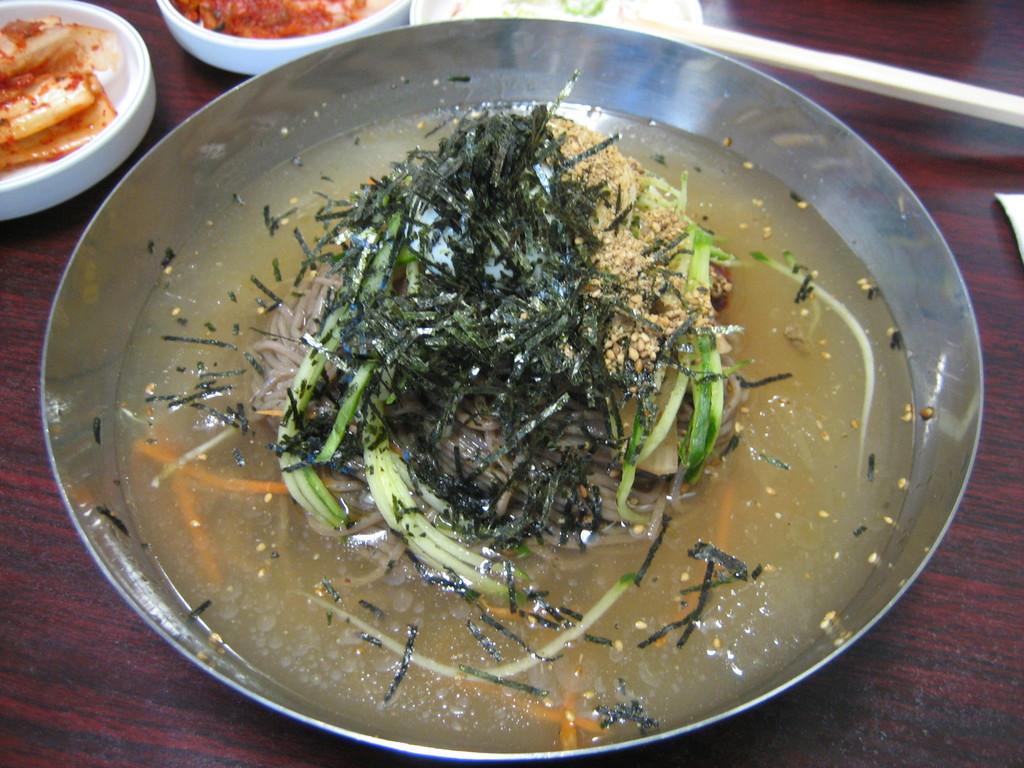In one or two sentences, can you explain what this image depicts? In this picture we can see food in the plate, beside the plate we can see bowls on the table. 